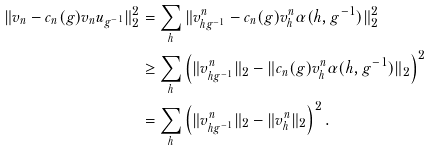<formula> <loc_0><loc_0><loc_500><loc_500>\| v _ { n } - c _ { n } ( g ) v _ { n } u _ { g ^ { - 1 } } \| ^ { 2 } _ { 2 } & = \sum _ { h } \| v ^ { n } _ { h g ^ { - 1 } } - c _ { n } ( g ) v ^ { n } _ { h } \alpha ( h , g ^ { - 1 } ) \| ^ { 2 } _ { 2 } \\ & \geq \sum _ { h } \left ( \| v ^ { n } _ { h g ^ { - 1 } } \| _ { 2 } - \| c _ { n } ( g ) v ^ { n } _ { h } \alpha ( h , g ^ { - 1 } ) \| _ { 2 } \right ) ^ { 2 } \\ & = \sum _ { h } \left ( \| v ^ { n } _ { h g ^ { - 1 } } \| _ { 2 } - \| v ^ { n } _ { h } \| _ { 2 } \right ) ^ { 2 } .</formula> 